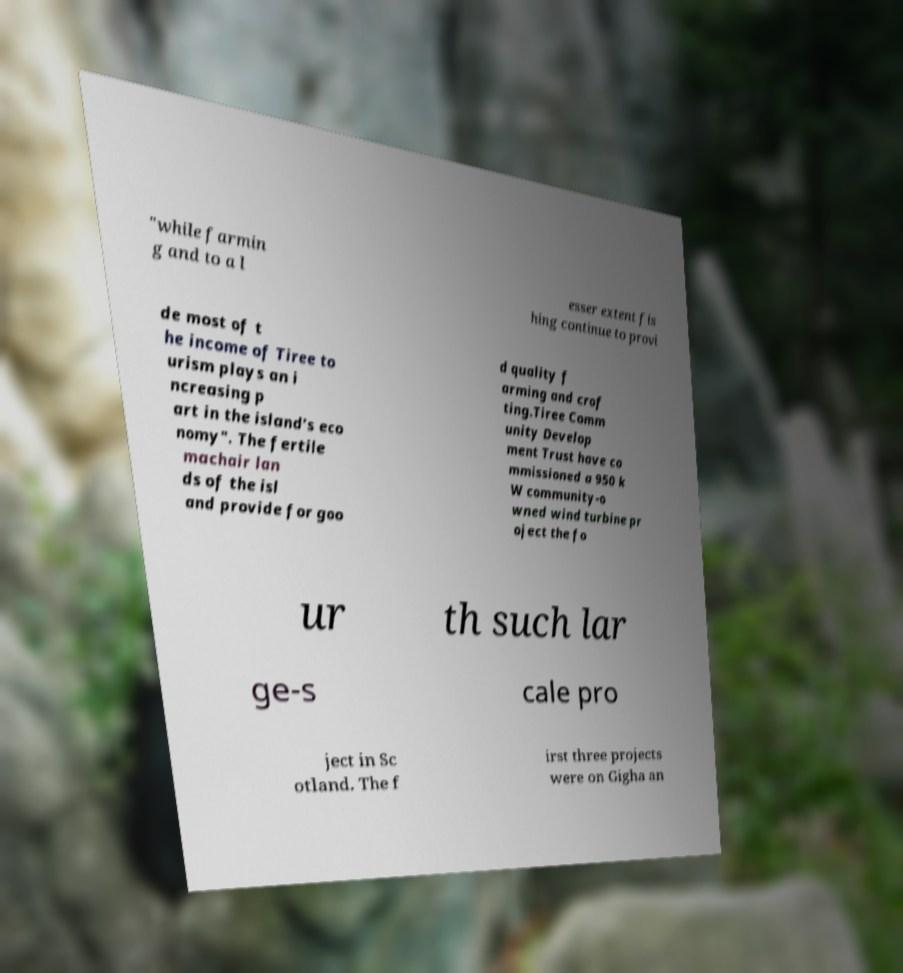What messages or text are displayed in this image? I need them in a readable, typed format. "while farmin g and to a l esser extent fis hing continue to provi de most of t he income of Tiree to urism plays an i ncreasing p art in the island’s eco nomy". The fertile machair lan ds of the isl and provide for goo d quality f arming and crof ting.Tiree Comm unity Develop ment Trust have co mmissioned a 950 k W community-o wned wind turbine pr oject the fo ur th such lar ge-s cale pro ject in Sc otland. The f irst three projects were on Gigha an 